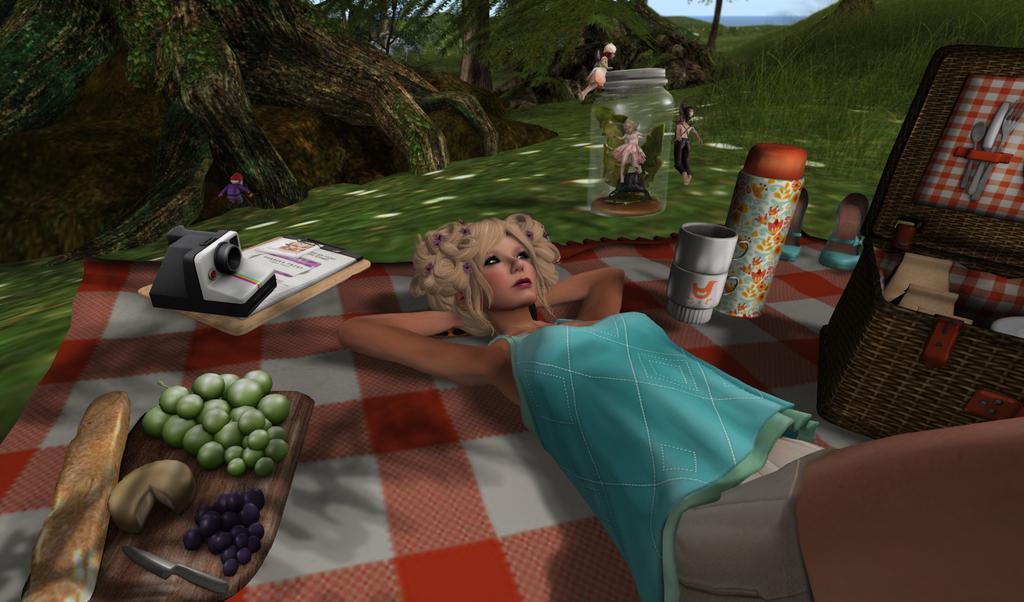In one or two sentences, can you explain what this image depicts? This is an animated image. I can see a camera, book to a clipboard, food items, knife, chopping board, cups, flask, footwear, a basket with objects and a woman lying on a cloth. In the background there are trees, hills, grass, a doll in a jar, three persons and I can see the sky. 